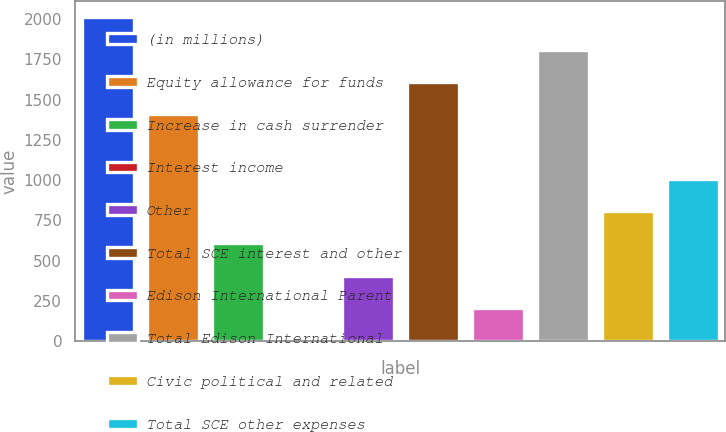<chart> <loc_0><loc_0><loc_500><loc_500><bar_chart><fcel>(in millions)<fcel>Equity allowance for funds<fcel>Increase in cash surrender<fcel>Interest income<fcel>Other<fcel>Total SCE interest and other<fcel>Edison International Parent<fcel>Total Edison International<fcel>Civic political and related<fcel>Total SCE other expenses<nl><fcel>2011<fcel>1409.2<fcel>606.8<fcel>5<fcel>406.2<fcel>1609.8<fcel>205.6<fcel>1810.4<fcel>807.4<fcel>1008<nl></chart> 